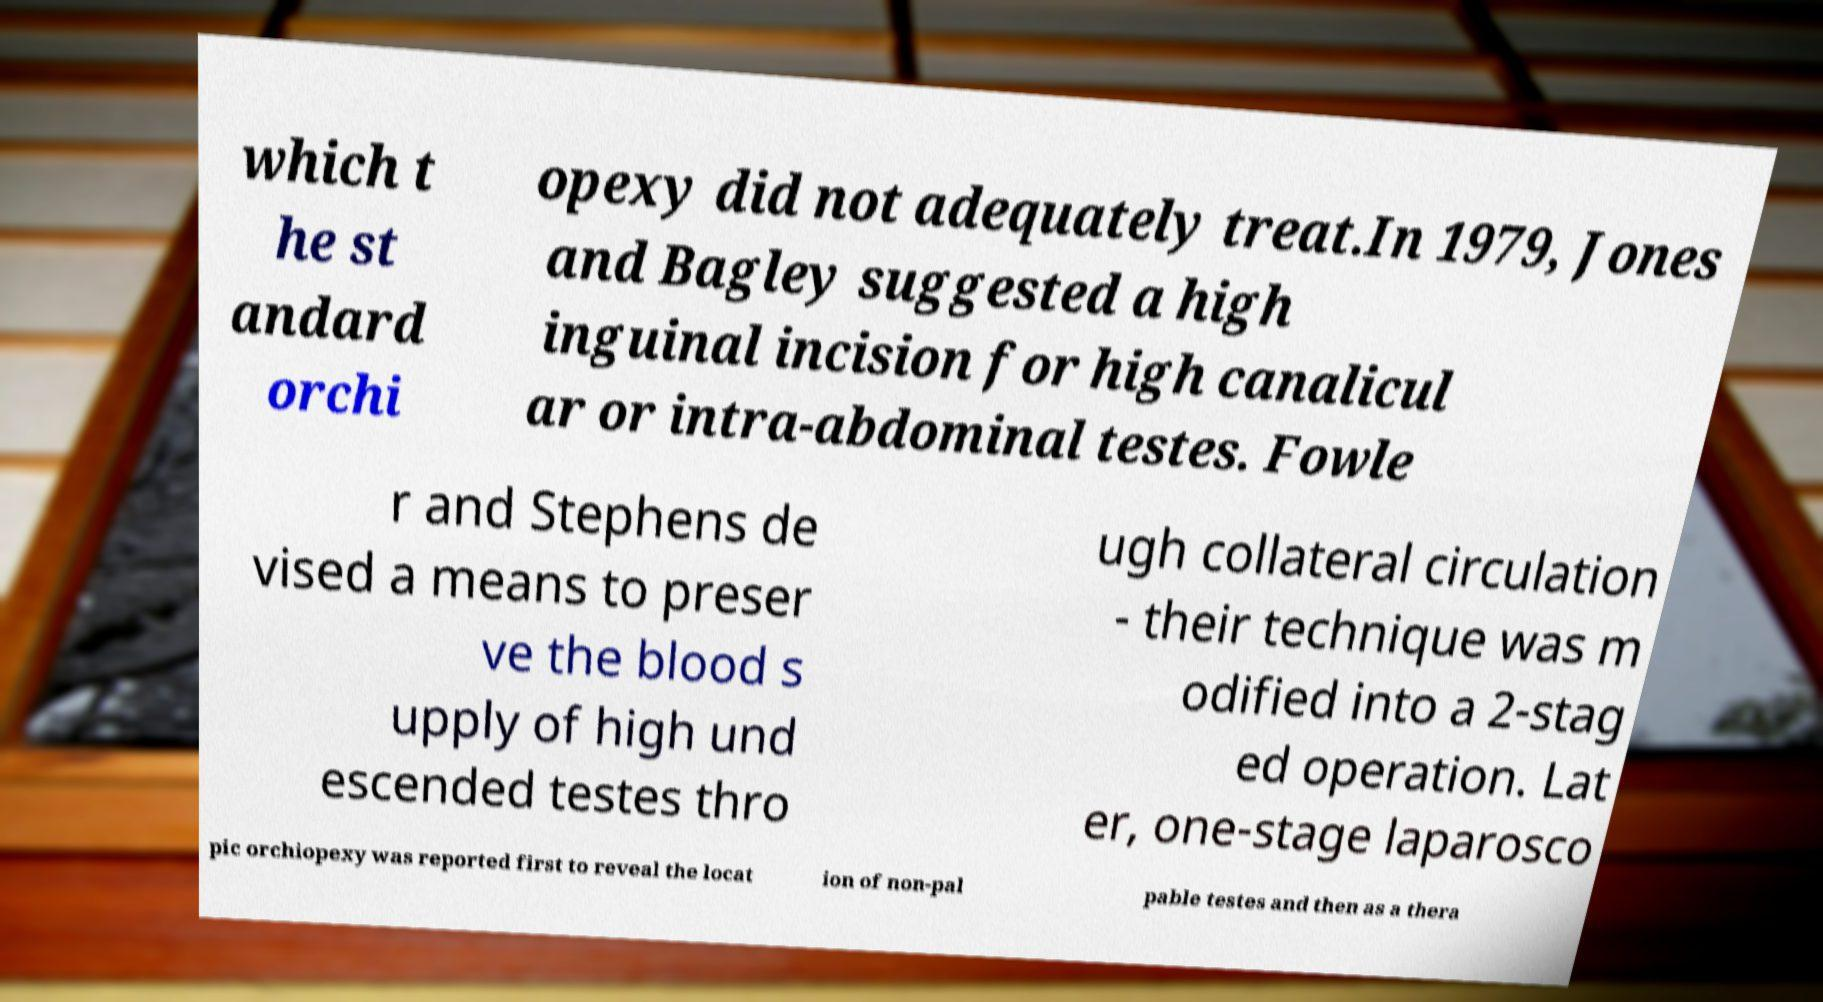Can you accurately transcribe the text from the provided image for me? which t he st andard orchi opexy did not adequately treat.In 1979, Jones and Bagley suggested a high inguinal incision for high canalicul ar or intra-abdominal testes. Fowle r and Stephens de vised a means to preser ve the blood s upply of high und escended testes thro ugh collateral circulation - their technique was m odified into a 2-stag ed operation. Lat er, one-stage laparosco pic orchiopexy was reported first to reveal the locat ion of non-pal pable testes and then as a thera 